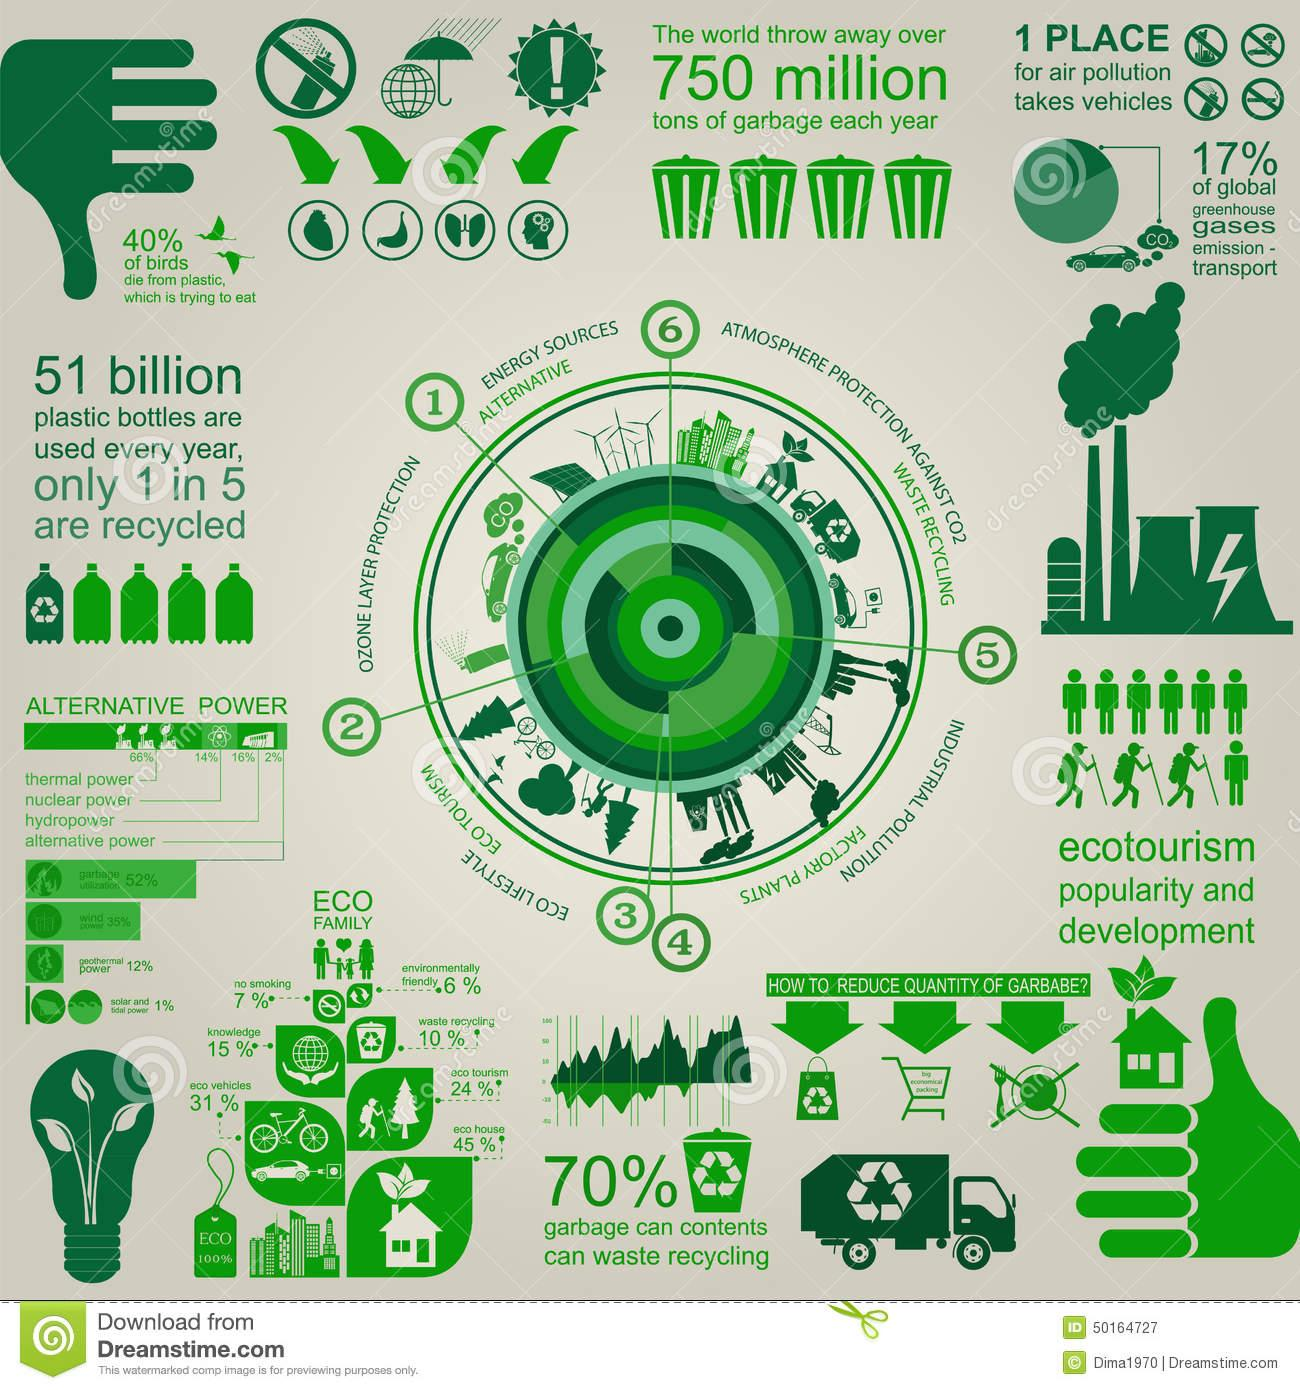Highlight a few significant elements in this photo. According to a recent study, approximately 60% of birds do not die as a result of plastic. The eco-family consists of a combination of eco-vehicles and knowledge, with a total of 46% of them. The eco-house and eco-tourism together constitute 69% of the eco-family, which is a significant portion. Thermal and nuclear power together constitute approximately 80% of the total power generation. In total, hydro and alternative power constitute 18% of the total power generated. 